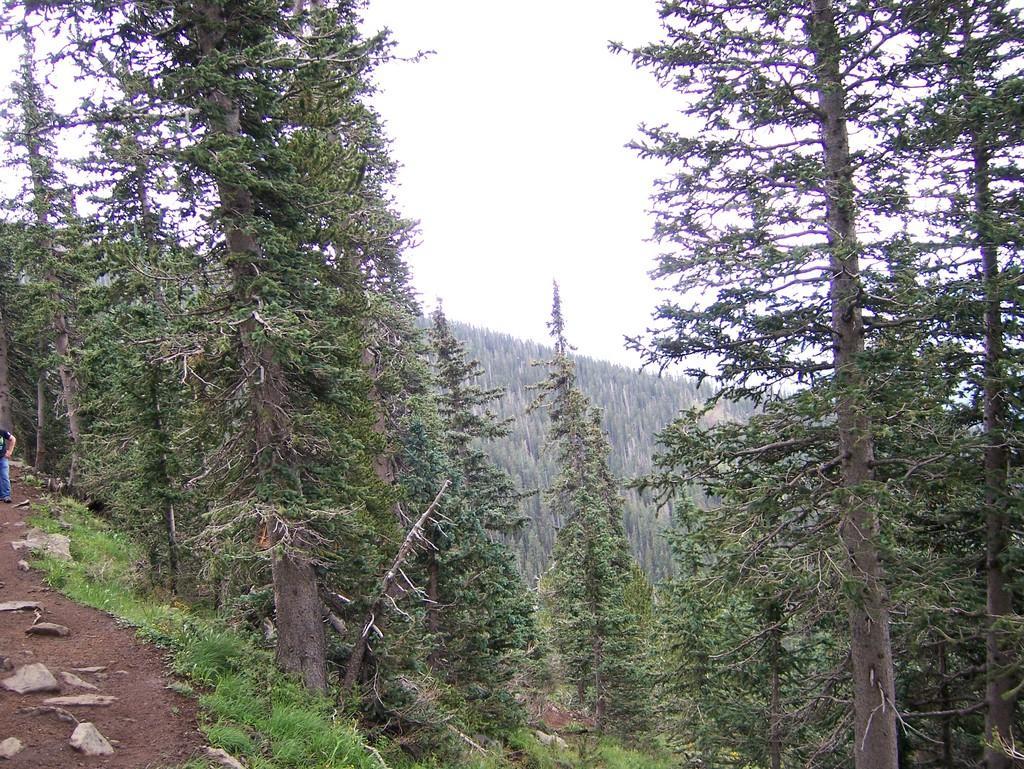Could you give a brief overview of what you see in this image? In this image there are many trees. To the left there is a walkway. Behind the walkway there's grass on the ground. To the extreme left there is a person standing. At the top there is the sky. 